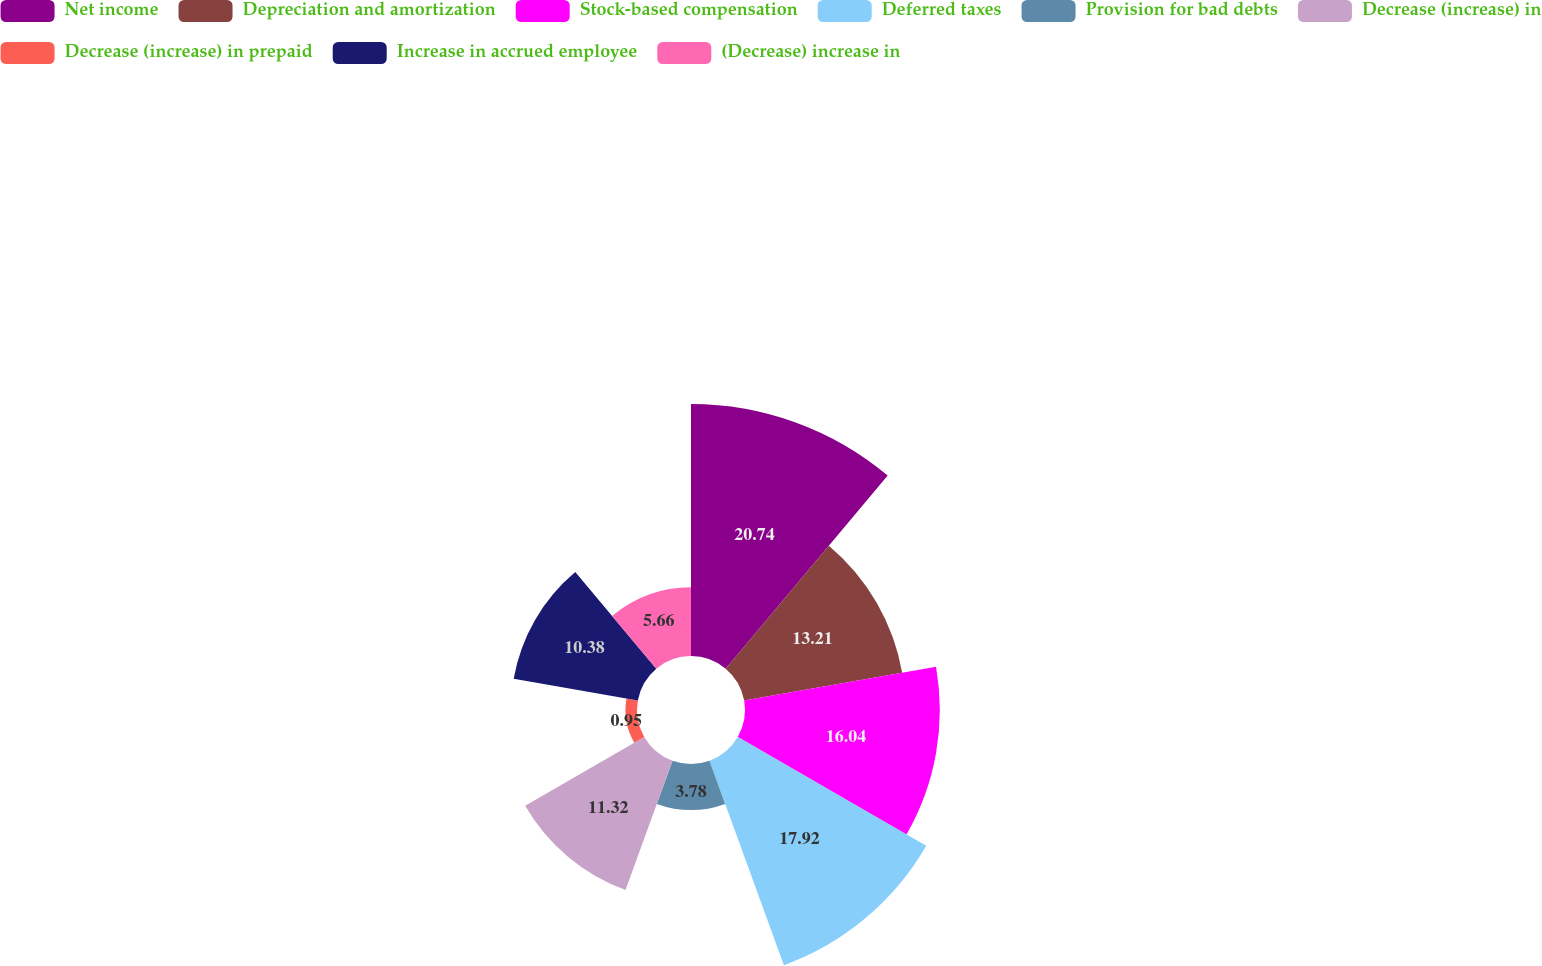Convert chart. <chart><loc_0><loc_0><loc_500><loc_500><pie_chart><fcel>Net income<fcel>Depreciation and amortization<fcel>Stock-based compensation<fcel>Deferred taxes<fcel>Provision for bad debts<fcel>Decrease (increase) in<fcel>Decrease (increase) in prepaid<fcel>Increase in accrued employee<fcel>(Decrease) increase in<nl><fcel>20.75%<fcel>13.21%<fcel>16.04%<fcel>17.92%<fcel>3.78%<fcel>11.32%<fcel>0.95%<fcel>10.38%<fcel>5.66%<nl></chart> 